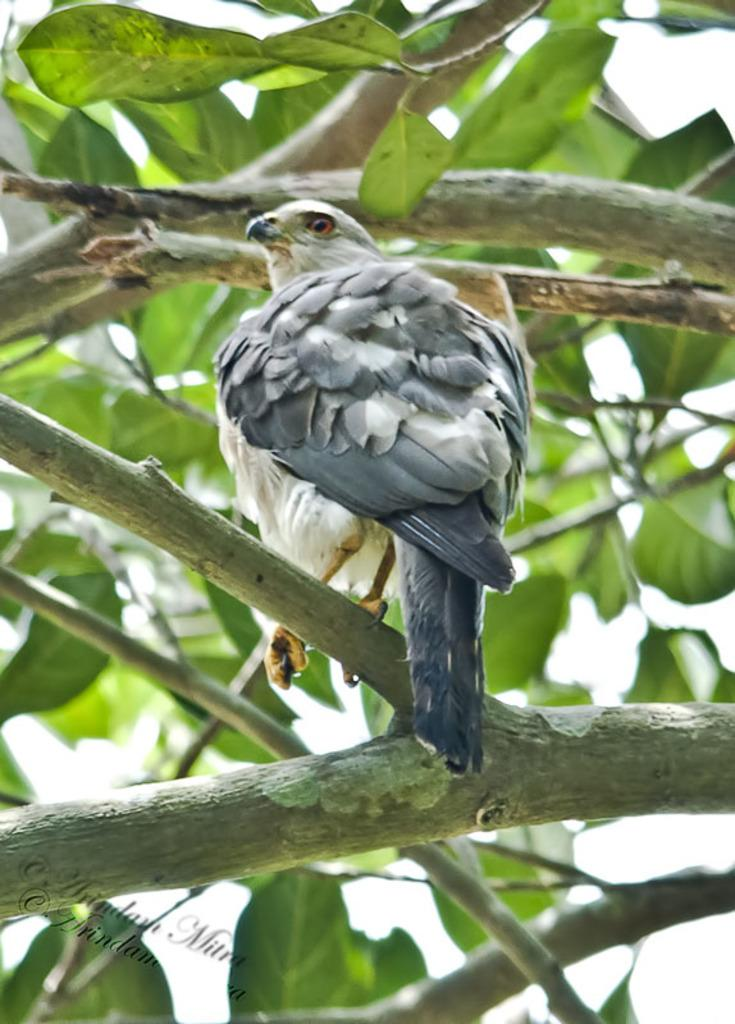What animal is present in the image? There is an eagle in the image. Where is the eagle located in the image? The eagle is sitting on a tree branch. What is the color of the eagle? The eagle is in grey color. What type of vegetation can be seen in the image? There are green leaves in the image. What note is the eagle playing on its silver tongue in the image? There is no note or silver tongue present in the image; the eagle is simply sitting on a tree branch. 